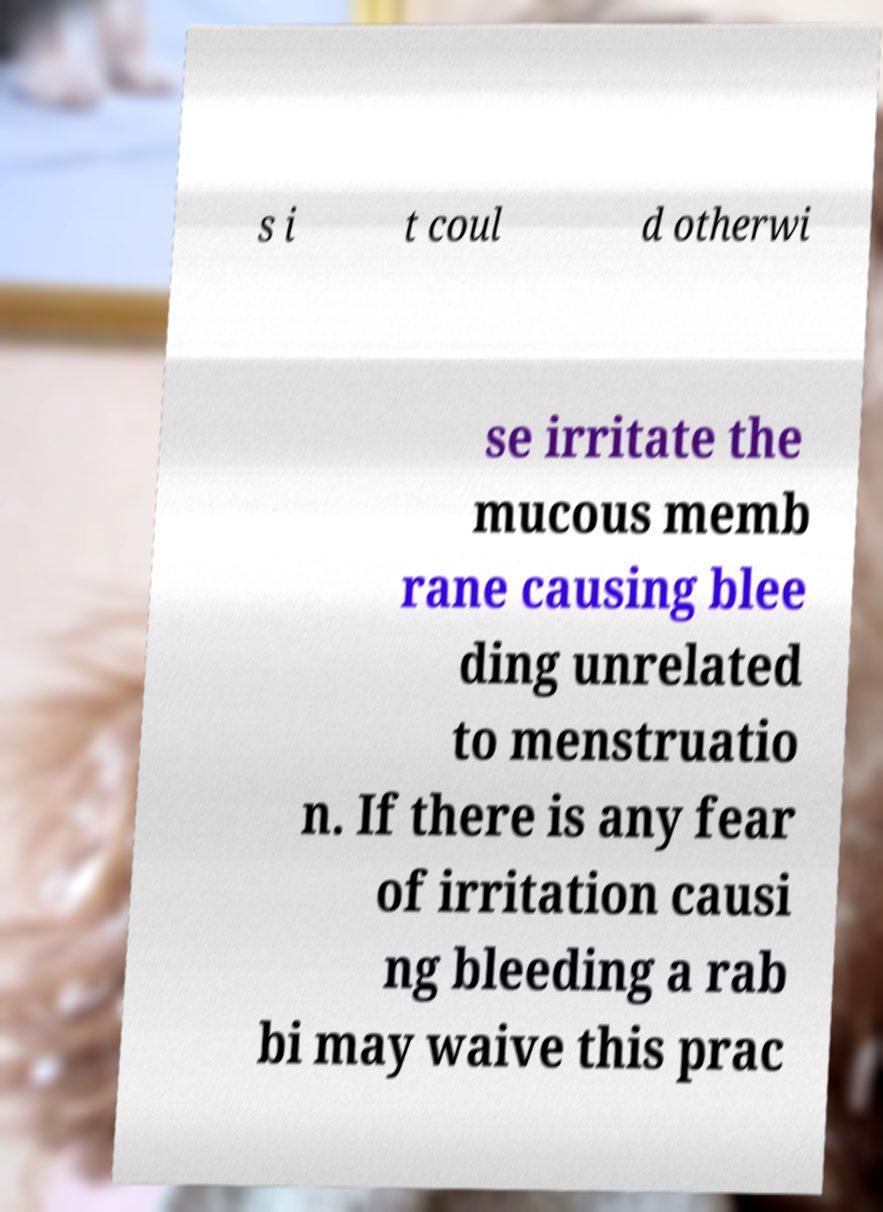Could you assist in decoding the text presented in this image and type it out clearly? s i t coul d otherwi se irritate the mucous memb rane causing blee ding unrelated to menstruatio n. If there is any fear of irritation causi ng bleeding a rab bi may waive this prac 